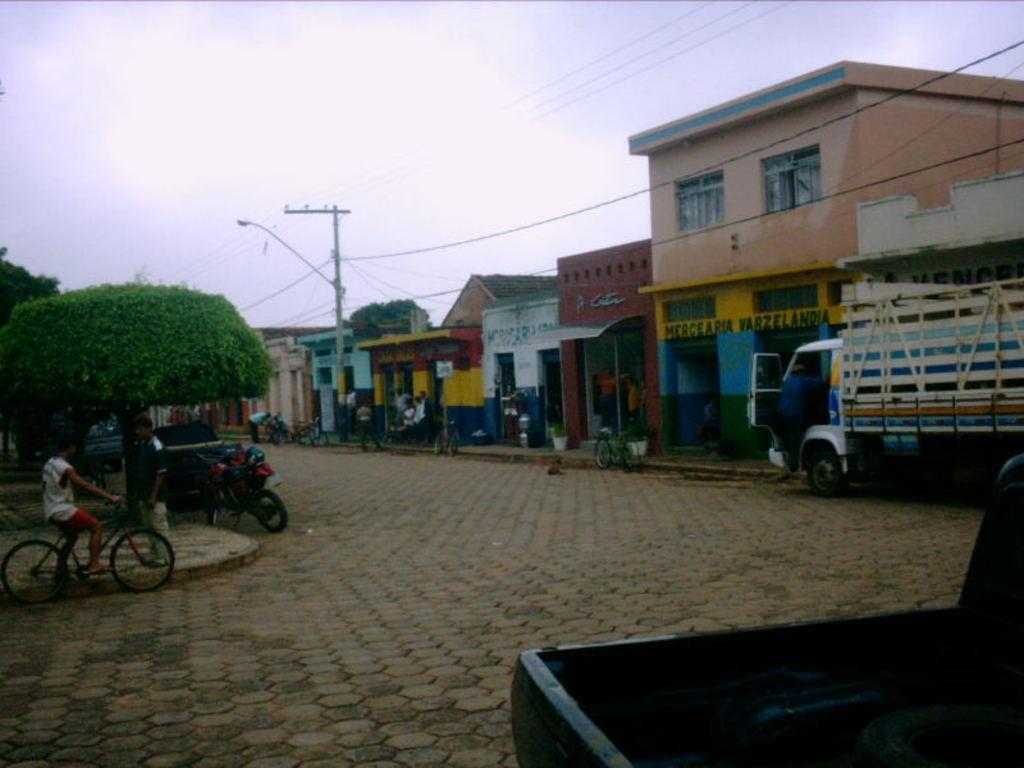How would you summarize this image in a sentence or two? In this image I see the path and I see a child on this cycle and I see few vehicles and I see few people and I see number of buildings and I see the trees. 